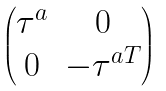<formula> <loc_0><loc_0><loc_500><loc_500>\begin{pmatrix} \tau ^ { a } & 0 \\ 0 & - \tau ^ { a T } \end{pmatrix}</formula> 